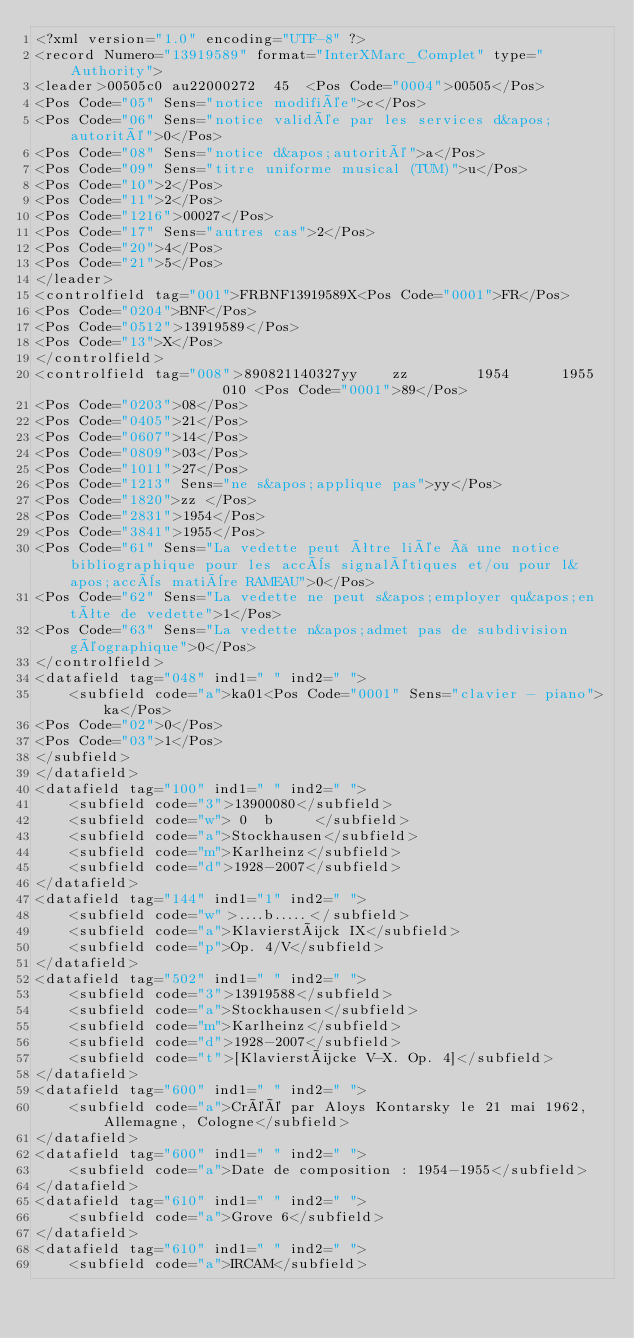<code> <loc_0><loc_0><loc_500><loc_500><_XML_><?xml version="1.0" encoding="UTF-8" ?>
<record Numero="13919589" format="InterXMarc_Complet" type="Authority">
<leader>00505c0 au22000272  45  <Pos Code="0004">00505</Pos>
<Pos Code="05" Sens="notice modifiée">c</Pos>
<Pos Code="06" Sens="notice validée par les services d&apos;autorité">0</Pos>
<Pos Code="08" Sens="notice d&apos;autorité">a</Pos>
<Pos Code="09" Sens="titre uniforme musical (TUM)">u</Pos>
<Pos Code="10">2</Pos>
<Pos Code="11">2</Pos>
<Pos Code="1216">00027</Pos>
<Pos Code="17" Sens="autres cas">2</Pos>
<Pos Code="20">4</Pos>
<Pos Code="21">5</Pos>
</leader>
<controlfield tag="001">FRBNF13919589X<Pos Code="0001">FR</Pos>
<Pos Code="0204">BNF</Pos>
<Pos Code="0512">13919589</Pos>
<Pos Code="13">X</Pos>
</controlfield>
<controlfield tag="008">890821140327yy    zz        1954      1955                   010 <Pos Code="0001">89</Pos>
<Pos Code="0203">08</Pos>
<Pos Code="0405">21</Pos>
<Pos Code="0607">14</Pos>
<Pos Code="0809">03</Pos>
<Pos Code="1011">27</Pos>
<Pos Code="1213" Sens="ne s&apos;applique pas">yy</Pos>
<Pos Code="1820">zz </Pos>
<Pos Code="2831">1954</Pos>
<Pos Code="3841">1955</Pos>
<Pos Code="61" Sens="La vedette peut être liée à une notice bibliographique pour les accès signalétiques et/ou pour l&apos;accès matière RAMEAU">0</Pos>
<Pos Code="62" Sens="La vedette ne peut s&apos;employer qu&apos;en tête de vedette">1</Pos>
<Pos Code="63" Sens="La vedette n&apos;admet pas de subdivision géographique">0</Pos>
</controlfield>
<datafield tag="048" ind1=" " ind2=" ">
	<subfield code="a">ka01<Pos Code="0001" Sens="clavier - piano">ka</Pos>
<Pos Code="02">0</Pos>
<Pos Code="03">1</Pos>
</subfield>
</datafield>
<datafield tag="100" ind1=" " ind2=" ">
	<subfield code="3">13900080</subfield>
	<subfield code="w"> 0  b     </subfield>
	<subfield code="a">Stockhausen</subfield>
	<subfield code="m">Karlheinz</subfield>
	<subfield code="d">1928-2007</subfield>
</datafield>
<datafield tag="144" ind1="1" ind2=" ">
	<subfield code="w">....b.....</subfield>
	<subfield code="a">Klavierstück IX</subfield>
	<subfield code="p">Op. 4/V</subfield>
</datafield>
<datafield tag="502" ind1=" " ind2=" ">
	<subfield code="3">13919588</subfield>
	<subfield code="a">Stockhausen</subfield>
	<subfield code="m">Karlheinz</subfield>
	<subfield code="d">1928-2007</subfield>
	<subfield code="t">[Klavierstücke V-X. Op. 4]</subfield>
</datafield>
<datafield tag="600" ind1=" " ind2=" ">
	<subfield code="a">Créé par Aloys Kontarsky le 21 mai 1962, Allemagne, Cologne</subfield>
</datafield>
<datafield tag="600" ind1=" " ind2=" ">
	<subfield code="a">Date de composition : 1954-1955</subfield>
</datafield>
<datafield tag="610" ind1=" " ind2=" ">
	<subfield code="a">Grove 6</subfield>
</datafield>
<datafield tag="610" ind1=" " ind2=" ">
	<subfield code="a">IRCAM</subfield></code> 